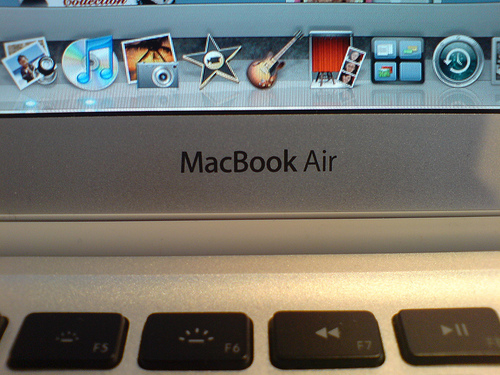<image>
Can you confirm if the app is in front of the screen? No. The app is not in front of the screen. The spatial positioning shows a different relationship between these objects. 